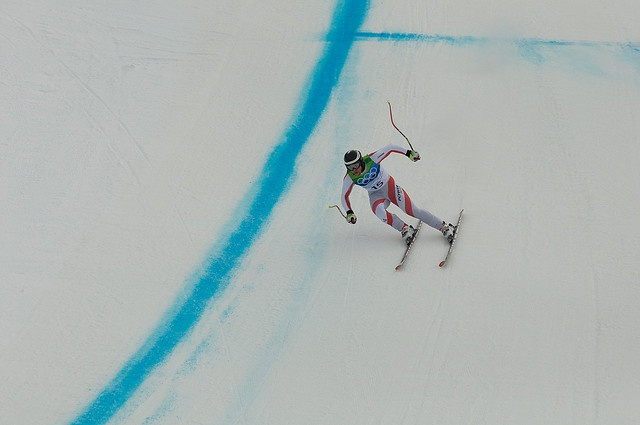Describe the objects in this image and their specific colors. I can see people in darkgray, gray, and black tones and skis in darkgray, gray, and black tones in this image. 